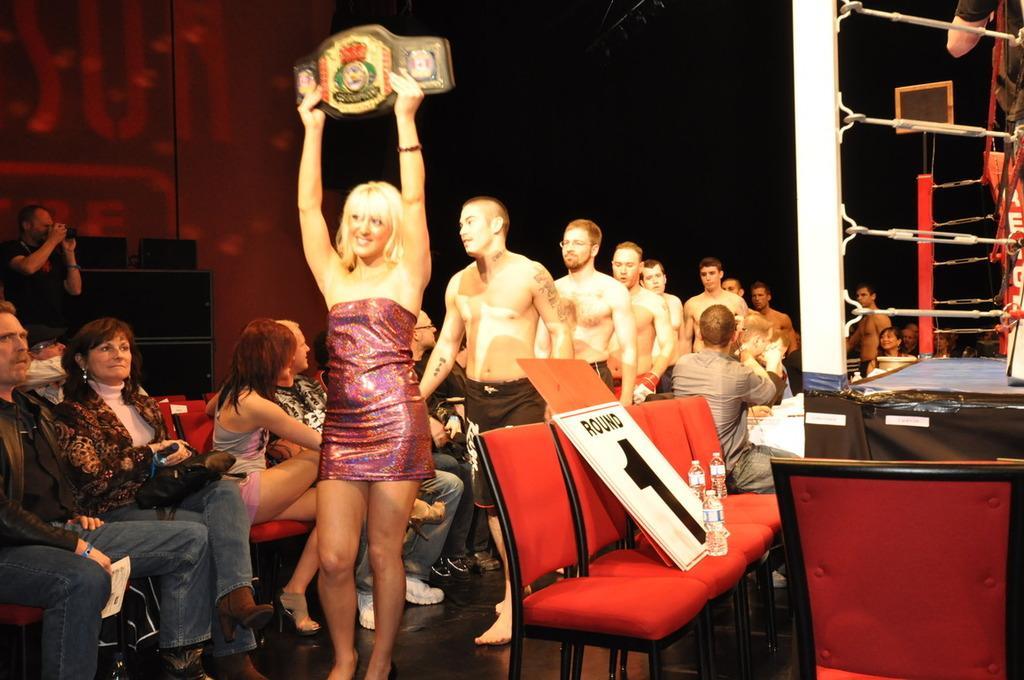Could you give a brief overview of what you see in this image? In the image we can see there is a woman who is standing and holding a belt and behind her there are lot of men standing and there are people sitting on chair. 